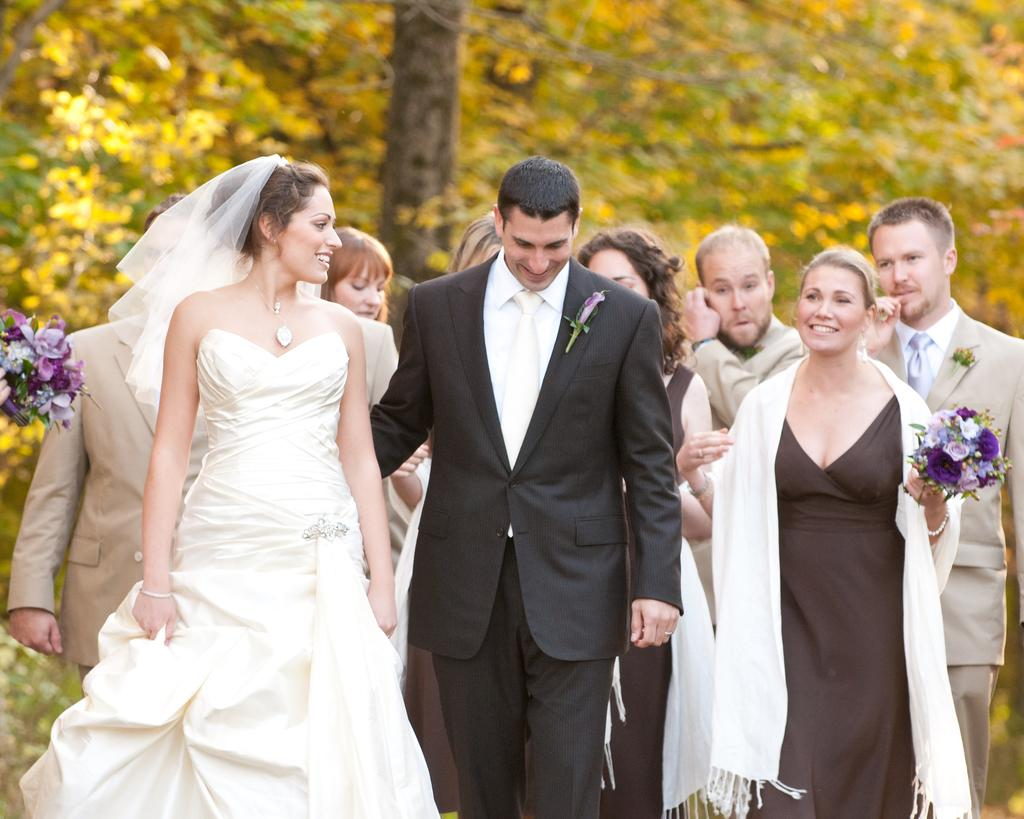How many people are in the image? There are multiple persons in the image. Can you describe the gender of the people in the image? There are both women and men in the image. What type of natural elements can be seen in the image? There are trees visible at the top of the image, and flowers on both the left and right sides of the image. What caption is written on the flowers in the image? There is no caption written on the flowers in the image; they are simply depicted as part of the natural scenery. 